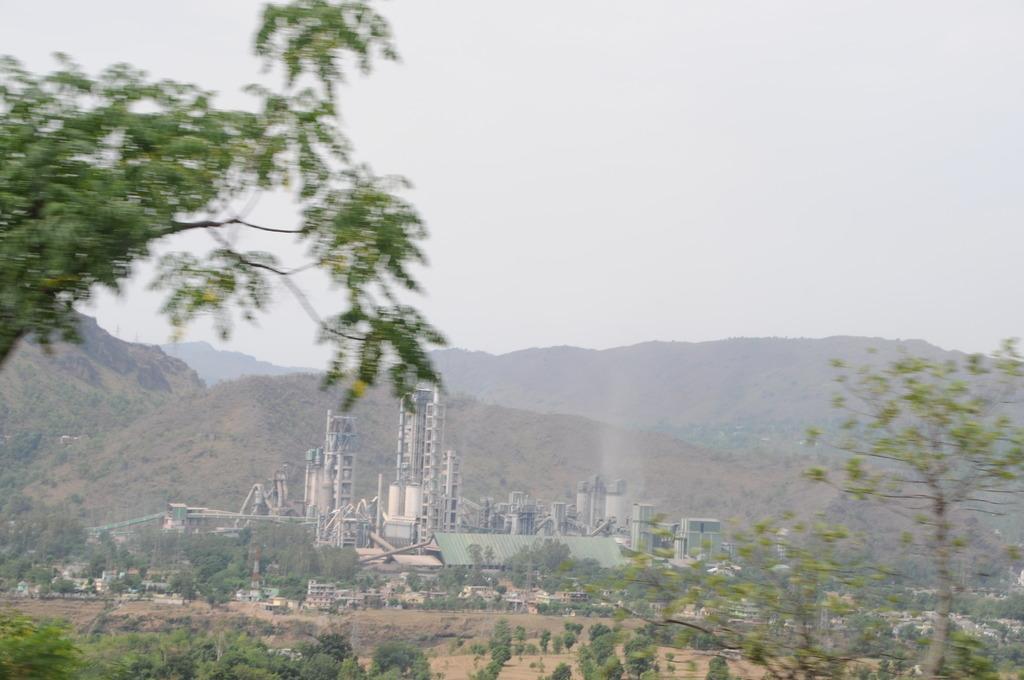Can you describe this image briefly? This looks like a factory. I can see the trees and plants. These are the mountains. Here is the sky. 